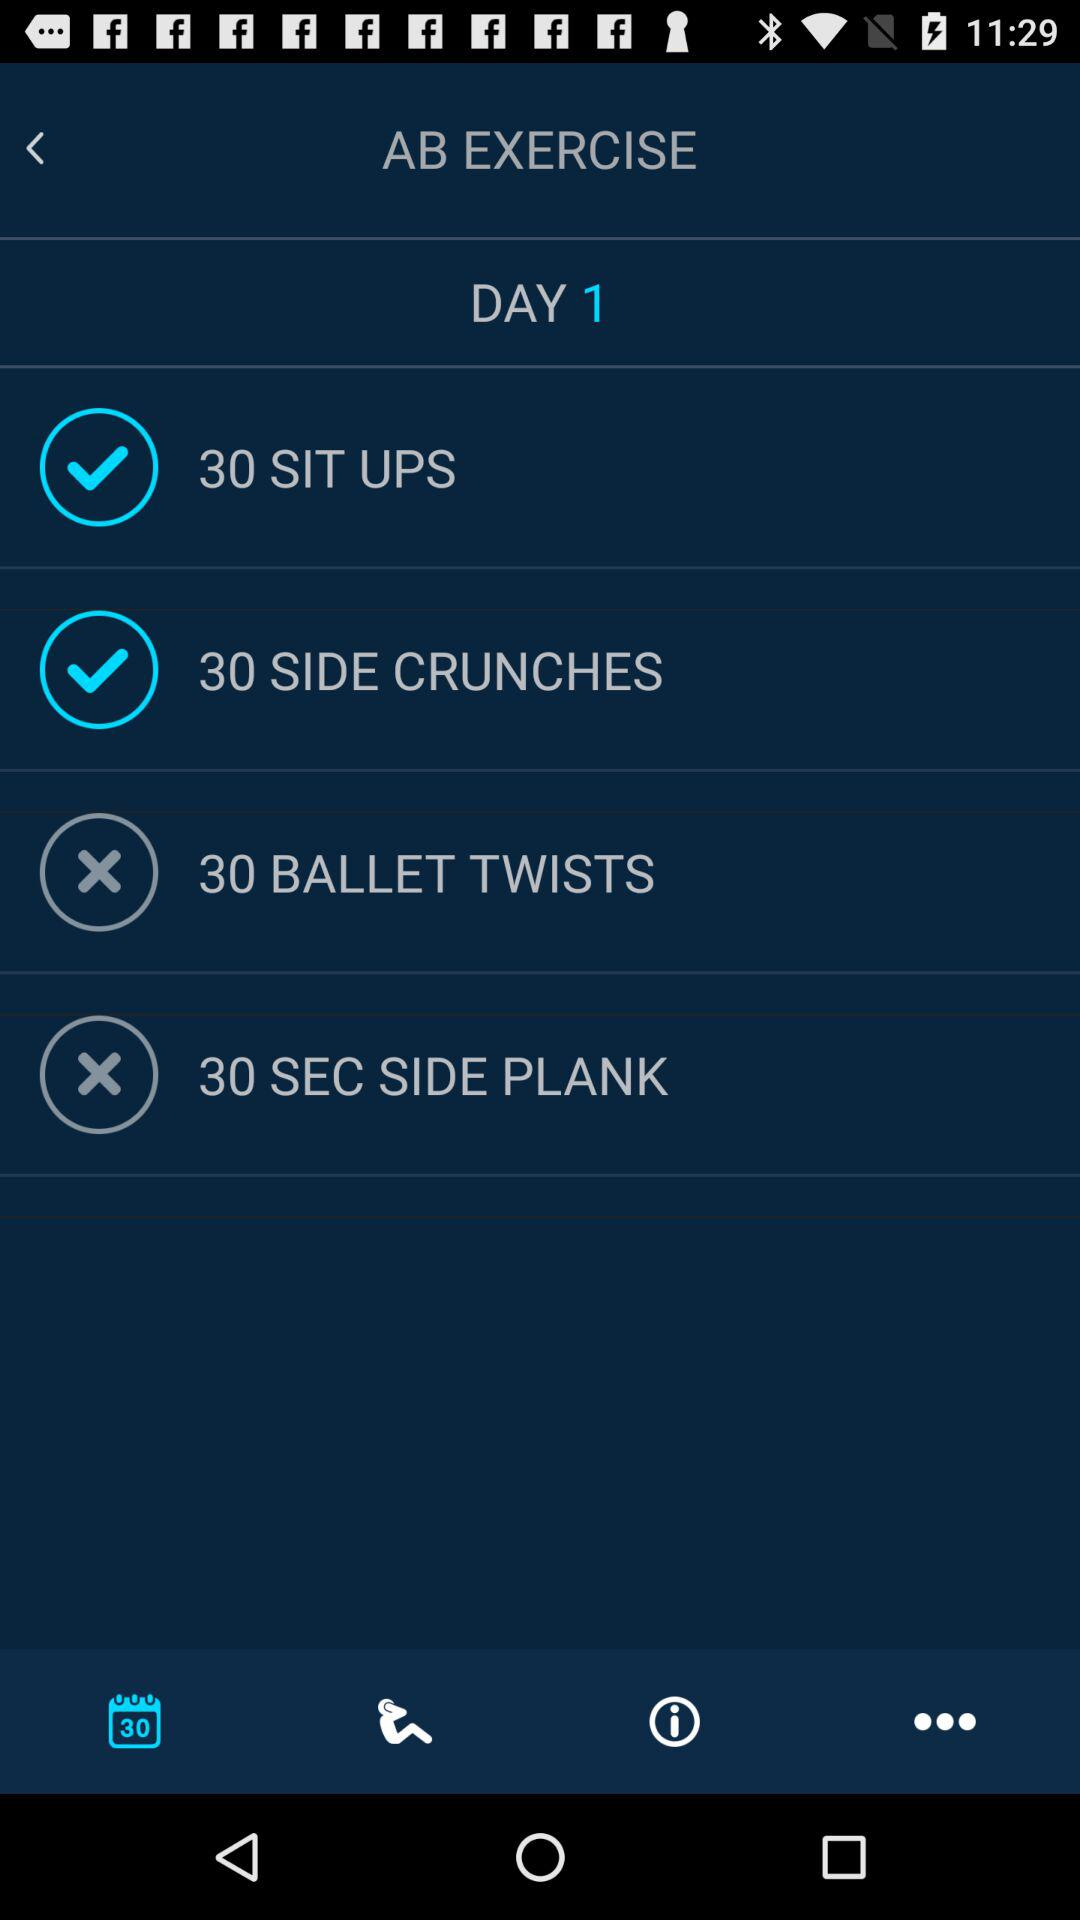What is the name of the exercise? The names of the exercises are "SIT UPS", "SIDE CRUNCHES", "BALLET TWISTS" and "SEC SIDE PLANK". 